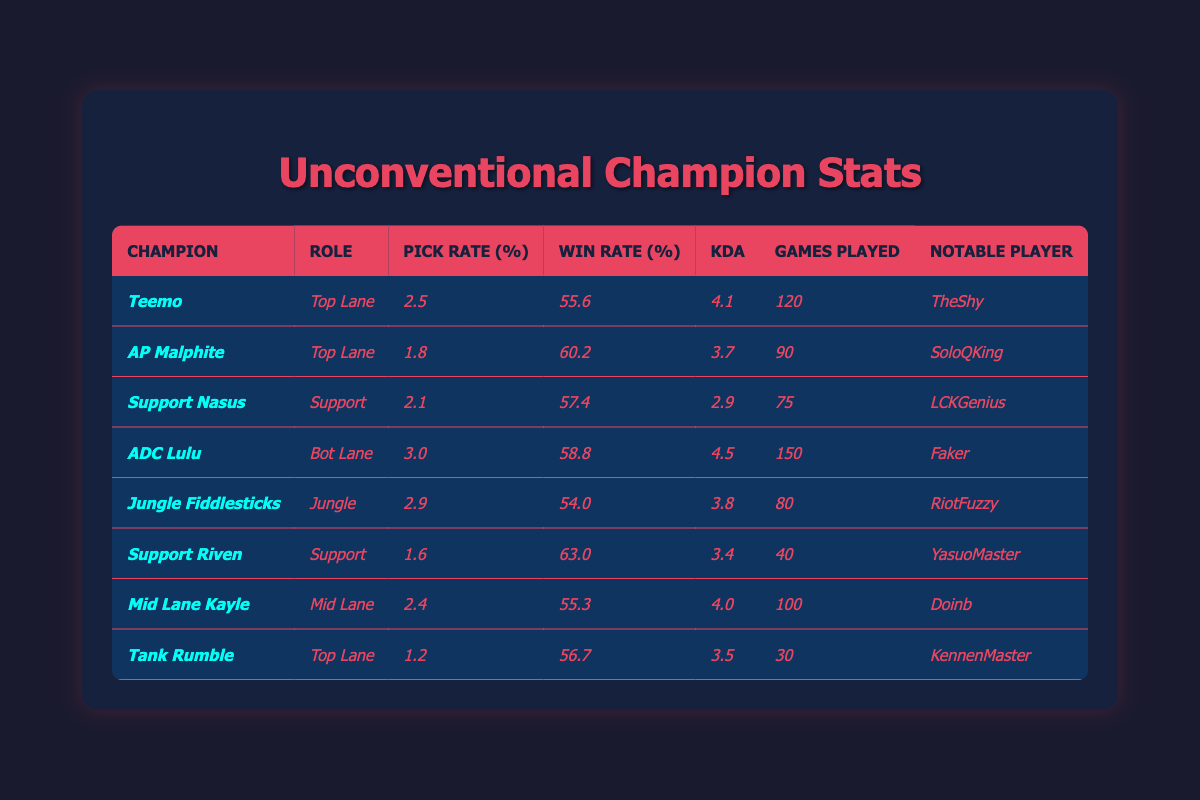What is the win rate percentage of ADC Lulu? According to the table, ADC Lulu has a win rate of 58.8%.
Answer: 58.8% Which champion has the highest KDA? The champion with the highest KDA is ADC Lulu with a KDA of 4.5.
Answer: ADC Lulu How many games were played with Support Riven? The table indicates that Support Riven was played in 40 games.
Answer: 40 What is the average pick rate of all champions listed in the table? To find the average, sum the pick rates: (2.5 + 1.8 + 2.1 + 3.0 + 2.9 + 1.6 + 2.4 + 1.2) = 15.5. There are 8 champions, so the average pick rate is 15.5/8 = 1.9375.
Answer: 1.94 Is the win rate of Teemo higher than that of Jungle Fiddlesticks? Teemo has a win rate of 55.6% and Jungle Fiddlesticks has a win rate of 54.0%. Since 55.6% > 54.0%, the statement is true.
Answer: Yes Which champion has the lowest pick rate and what is that rate? The champion with the lowest pick rate is Tank Rumble, with a pick rate of 1.2%.
Answer: Tank Rumble, 1.2% What is the difference in win rate between AP Malphite and Support Nasus? AP Malphite has a win rate of 60.2% and Support Nasus has a win rate of 57.4%. The difference is 60.2% - 57.4% = 2.8%.
Answer: 2.8% Which champion has the most games played? ADC Lulu has the most games played, totaling 150 games.
Answer: ADC Lulu Does Support Riven have a higher win rate than the average win rate of all champions listed? The average win rate can be calculated as (55.6 + 60.2 + 57.4 + 58.8 + 54.0 + 63.0 + 55.3 + 56.7) = 426.0; dividing by 8 gives an average win rate of 53.25%. Since Support Riven has a win rate of 63.0%, it is higher than the average.
Answer: Yes What role does Tank Rumble play and what is his KDA? Tank Rumble plays Top Lane and has a KDA of 3.5.
Answer: Top Lane, 3.5 